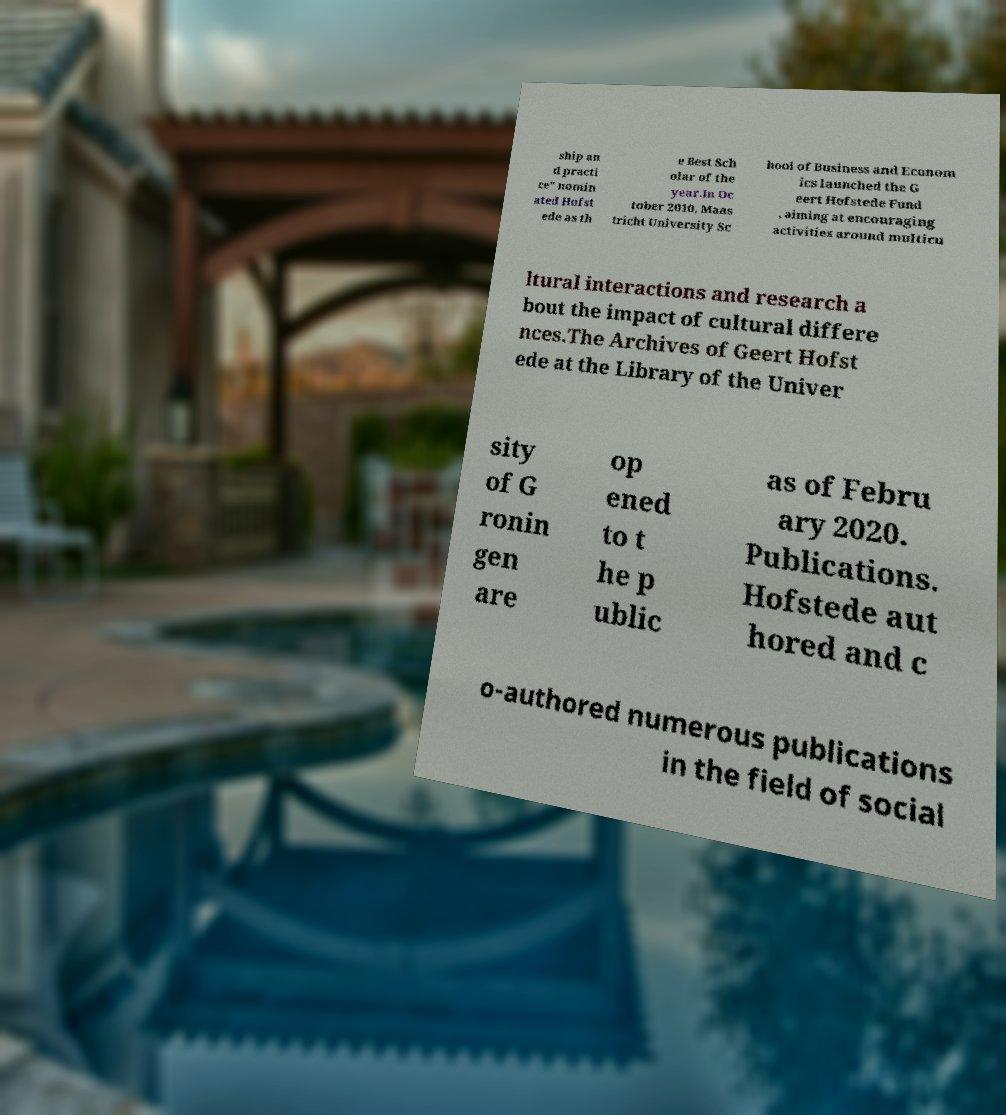Please identify and transcribe the text found in this image. ship an d practi ce" nomin ated Hofst ede as th e Best Sch olar of the year.In Oc tober 2010, Maas tricht University Sc hool of Business and Econom ics launched the G eert Hofstede Fund , aiming at encouraging activities around multicu ltural interactions and research a bout the impact of cultural differe nces.The Archives of Geert Hofst ede at the Library of the Univer sity of G ronin gen are op ened to t he p ublic as of Febru ary 2020. Publications. Hofstede aut hored and c o-authored numerous publications in the field of social 